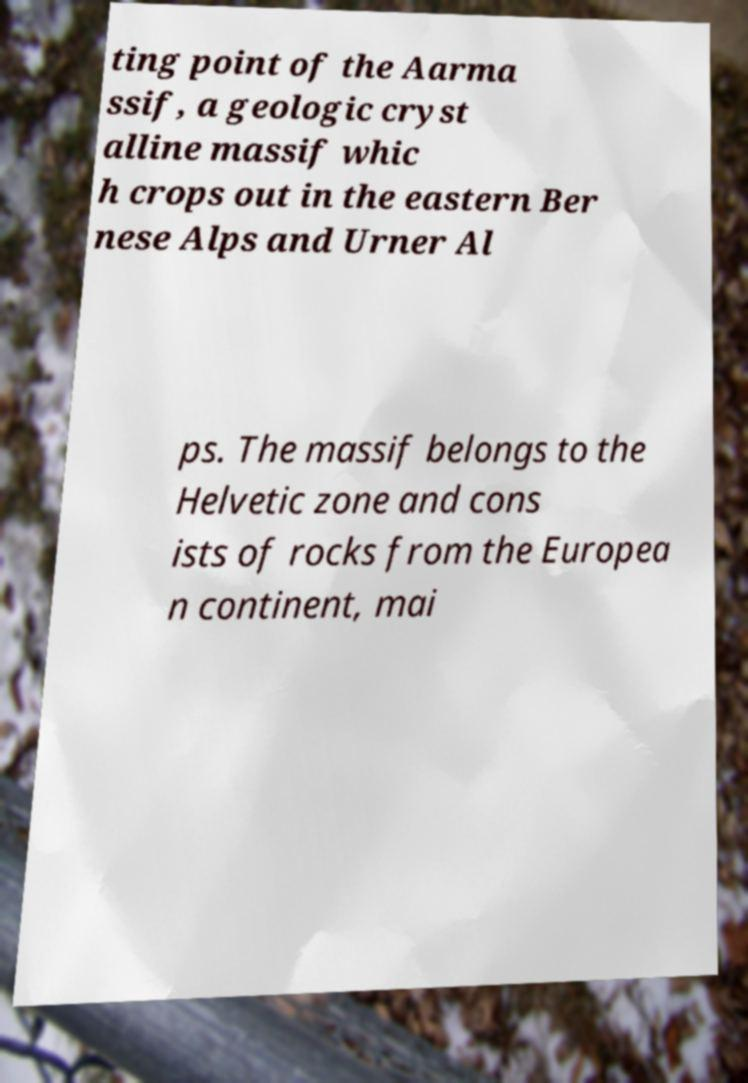I need the written content from this picture converted into text. Can you do that? ting point of the Aarma ssif, a geologic cryst alline massif whic h crops out in the eastern Ber nese Alps and Urner Al ps. The massif belongs to the Helvetic zone and cons ists of rocks from the Europea n continent, mai 